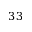Convert formula to latex. <formula><loc_0><loc_0><loc_500><loc_500>3 3</formula> 